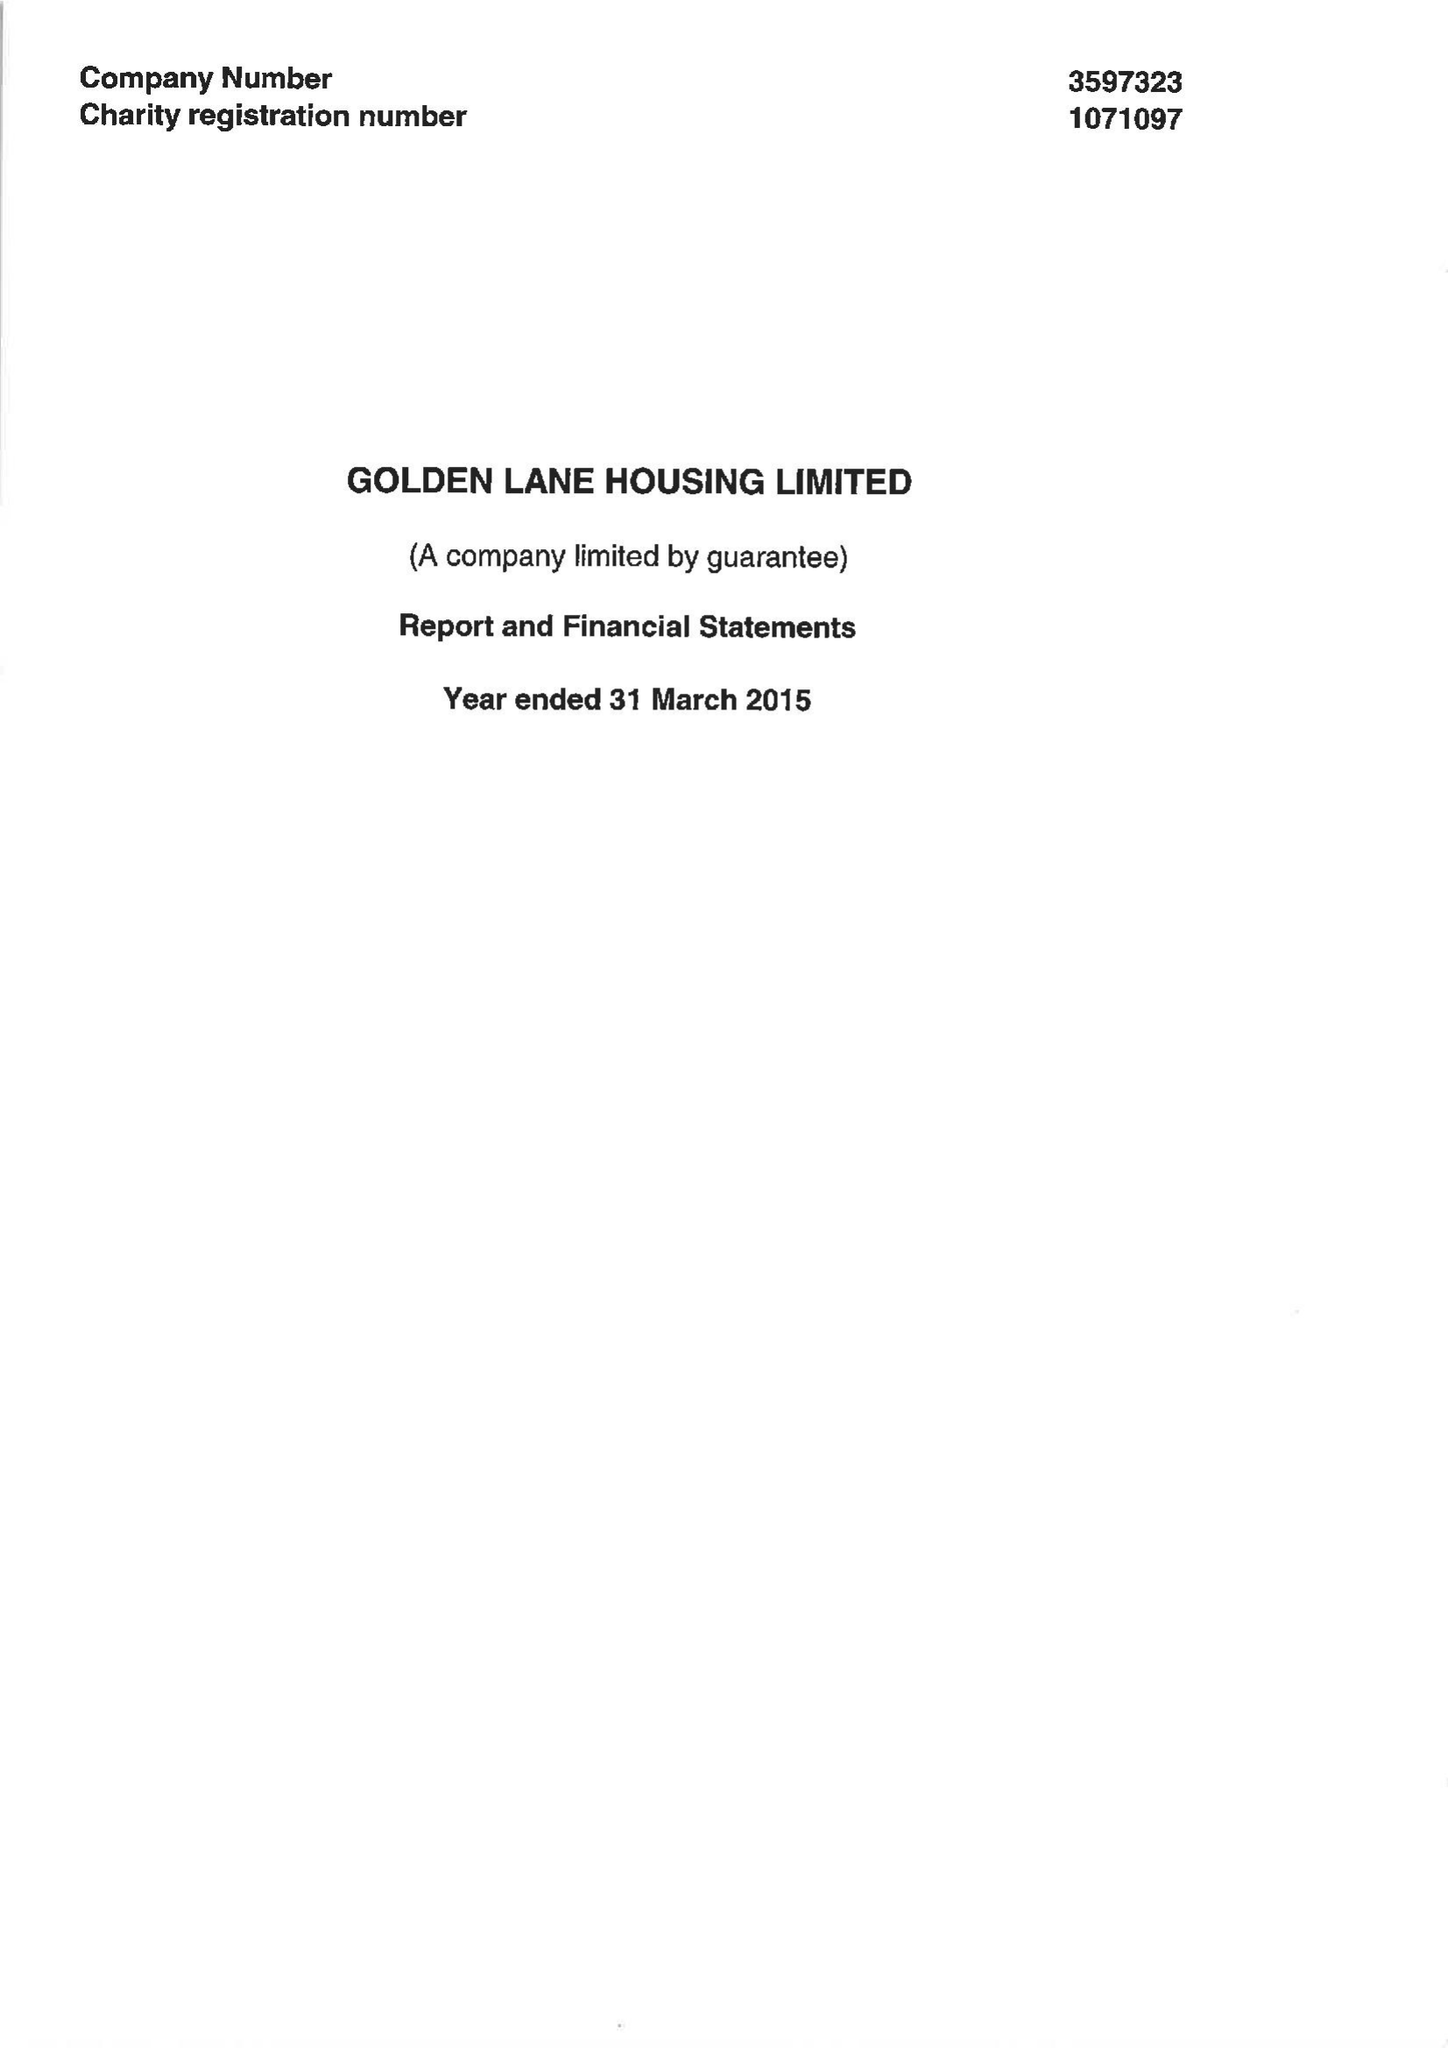What is the value for the report_date?
Answer the question using a single word or phrase. 2015-03-31 